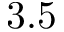Convert formula to latex. <formula><loc_0><loc_0><loc_500><loc_500>3 . 5</formula> 